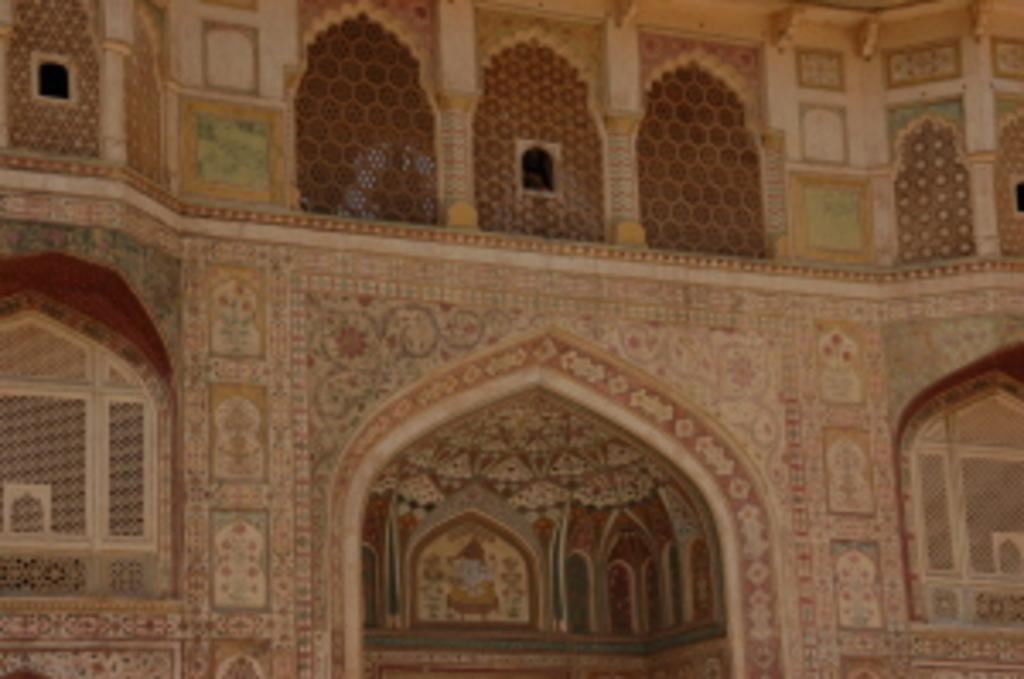What type of structure is in the image? There is a building in the image. What architectural features can be seen on the building? Windows and walls are visible in the image. What grade of wood was used to construct the building in the image? There is no information about the grade of wood used in the construction of the building in the image. 